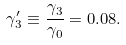<formula> <loc_0><loc_0><loc_500><loc_500>\gamma _ { 3 } ^ { \prime } \equiv \frac { \gamma _ { 3 } } { \gamma _ { 0 } } = 0 . 0 8 .</formula> 